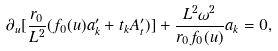<formula> <loc_0><loc_0><loc_500><loc_500>\partial _ { u } [ \frac { r _ { 0 } } { L ^ { 2 } } ( f _ { 0 } ( u ) a ^ { \prime } _ { k } + t _ { k } A ^ { \prime } _ { t } ) ] + \frac { L ^ { 2 } \omega ^ { 2 } } { r _ { 0 } f _ { 0 } ( u ) } a _ { k } = 0 ,</formula> 